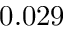Convert formula to latex. <formula><loc_0><loc_0><loc_500><loc_500>0 . 0 2 9</formula> 